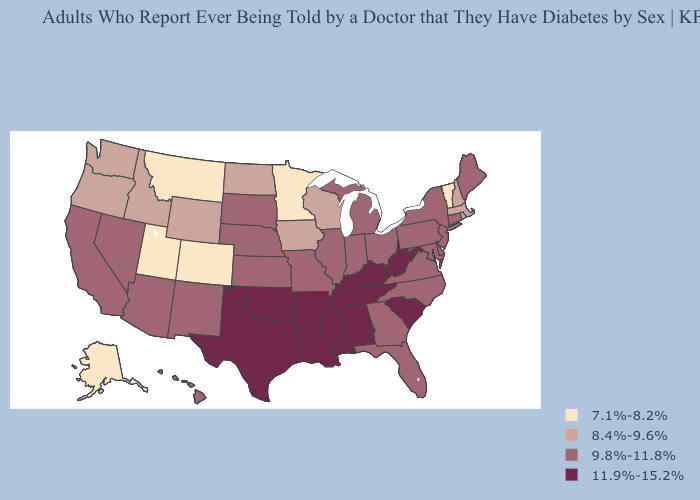Does the first symbol in the legend represent the smallest category?
Quick response, please. Yes. What is the value of Tennessee?
Quick response, please. 11.9%-15.2%. Which states have the lowest value in the South?
Answer briefly. Delaware, Florida, Georgia, Maryland, North Carolina, Virginia. What is the lowest value in the Northeast?
Write a very short answer. 7.1%-8.2%. Name the states that have a value in the range 9.8%-11.8%?
Give a very brief answer. Arizona, California, Connecticut, Delaware, Florida, Georgia, Hawaii, Illinois, Indiana, Kansas, Maine, Maryland, Michigan, Missouri, Nebraska, Nevada, New Jersey, New Mexico, New York, North Carolina, Ohio, Pennsylvania, South Dakota, Virginia. Among the states that border Kansas , which have the highest value?
Short answer required. Oklahoma. What is the lowest value in states that border Wisconsin?
Give a very brief answer. 7.1%-8.2%. Is the legend a continuous bar?
Quick response, please. No. What is the highest value in the South ?
Be succinct. 11.9%-15.2%. Among the states that border Georgia , which have the lowest value?
Write a very short answer. Florida, North Carolina. What is the value of Oklahoma?
Answer briefly. 11.9%-15.2%. Name the states that have a value in the range 7.1%-8.2%?
Be succinct. Alaska, Colorado, Minnesota, Montana, Utah, Vermont. Name the states that have a value in the range 11.9%-15.2%?
Write a very short answer. Alabama, Arkansas, Kentucky, Louisiana, Mississippi, Oklahoma, South Carolina, Tennessee, Texas, West Virginia. What is the value of Georgia?
Answer briefly. 9.8%-11.8%. Among the states that border South Carolina , which have the highest value?
Short answer required. Georgia, North Carolina. 